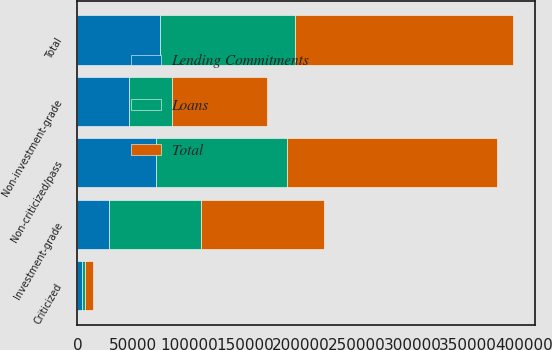Convert chart to OTSL. <chart><loc_0><loc_0><loc_500><loc_500><stacked_bar_chart><ecel><fcel>Investment-grade<fcel>Non-investment-grade<fcel>Total<fcel>Non-criticized/pass<fcel>Criticized<nl><fcel>Lending Commitments<fcel>28290<fcel>45788<fcel>74078<fcel>70153<fcel>3925<nl><fcel>Loans<fcel>81959<fcel>39038<fcel>120997<fcel>117923<fcel>3074<nl><fcel>Total<fcel>110249<fcel>84826<fcel>195075<fcel>188076<fcel>6999<nl></chart> 